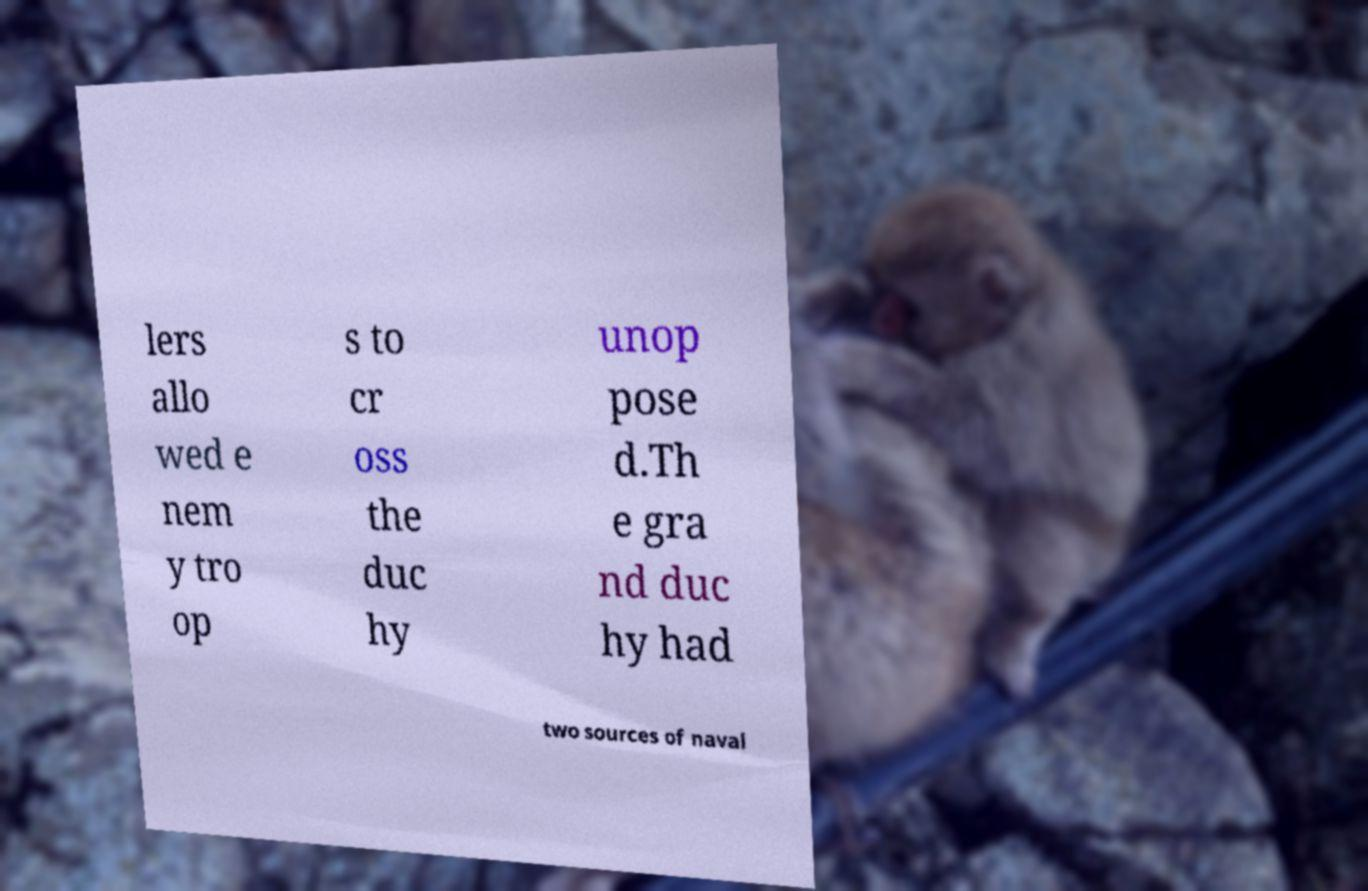What messages or text are displayed in this image? I need them in a readable, typed format. lers allo wed e nem y tro op s to cr oss the duc hy unop pose d.Th e gra nd duc hy had two sources of naval 